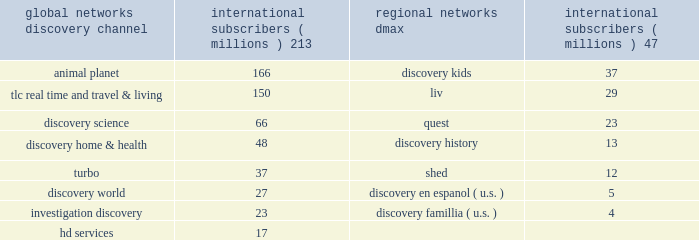Our digital media business consists of our websites and mobile and video-on-demand ( 201cvod 201d ) services .
Our websites include network branded websites such as discovery.com , tlc.com and animalplanet.com , and other websites such as howstuffworks.com , an online source of explanations of how the world actually works ; treehugger.com , a comprehensive source for 201cgreen 201d news , solutions and product information ; and petfinder.com , a leading pet adoption destination .
Together , these websites attracted an average of 24 million cumulative unique monthly visitors , according to comscore , inc .
In 2011 .
International networks our international networks segment principally consists of national and pan-regional television networks .
This segment generates revenues primarily from fees charged to operators who distribute our networks , which primarily include cable and dth satellite service providers , and from advertising sold on our television networks and websites .
Discovery channel , animal planet and tlc lead the international networks 2019 portfolio of television networks , which are distributed in virtually every pay-television market in the world through an infrastructure that includes operational centers in london , singapore and miami .
International networks has one of the largest international distribution platforms of networks with one to twelve networks in more than 200 countries and territories around the world .
At december 31 , 2011 , international networks operated over 150 unique distribution feeds in over 40 languages with channel feeds customized according to language needs and advertising sales opportunities .
Our international networks segment owns and operates the following television networks which reached the following number of subscribers as of december 31 , 2011 : education and other our education and other segment primarily includes the sale of curriculum-based product and service offerings and postproduction audio services .
This segment generates revenues primarily from subscriptions charged to k-12 schools for access to an online suite of curriculum-based vod tools , professional development services , and to a lesser extent student assessment and publication of hardcopy curriculum-based content .
Our education business also participates in corporate partnerships , global brand and content licensing business with leading non-profits , foundations and trade associations .
Other businesses primarily include postproduction audio services that are provided to major motion picture studios , independent producers , broadcast networks , cable channels , advertising agencies , and interactive producers .
Content development our content development strategy is designed to increase viewership , maintain innovation and quality leadership , and provide value for our network distributors and advertising customers .
Substantially all content is sourced from a wide range of third-party producers , which includes some of the world 2019s leading nonfiction production companies with which we have developed long-standing relationships , as well as independent producers .
Our production arrangements fall into three categories : produced , coproduced and licensed .
Substantially all produced content includes programming which we engage third parties to develop and produce while we retain editorial control and own most or all of the rights in exchange for paying all development and production costs .
Coproduced content refers to program rights acquired that we have collaborated with third parties to finance and develop .
Coproduced programs are typically high-cost projects for which neither we nor our coproducers wish to bear the entire cost or productions in which the producer has already taken on an international broadcast partner .
Licensed content is comprised of films or series that have been previously produced by third parties .
Global networks international subscribers ( millions ) regional networks international subscribers ( millions ) .

What is the difference in millions of subscribers between discovery channel international subscribers and discovery science international subscribers? 
Computations: (213 - 66)
Answer: 147.0. 